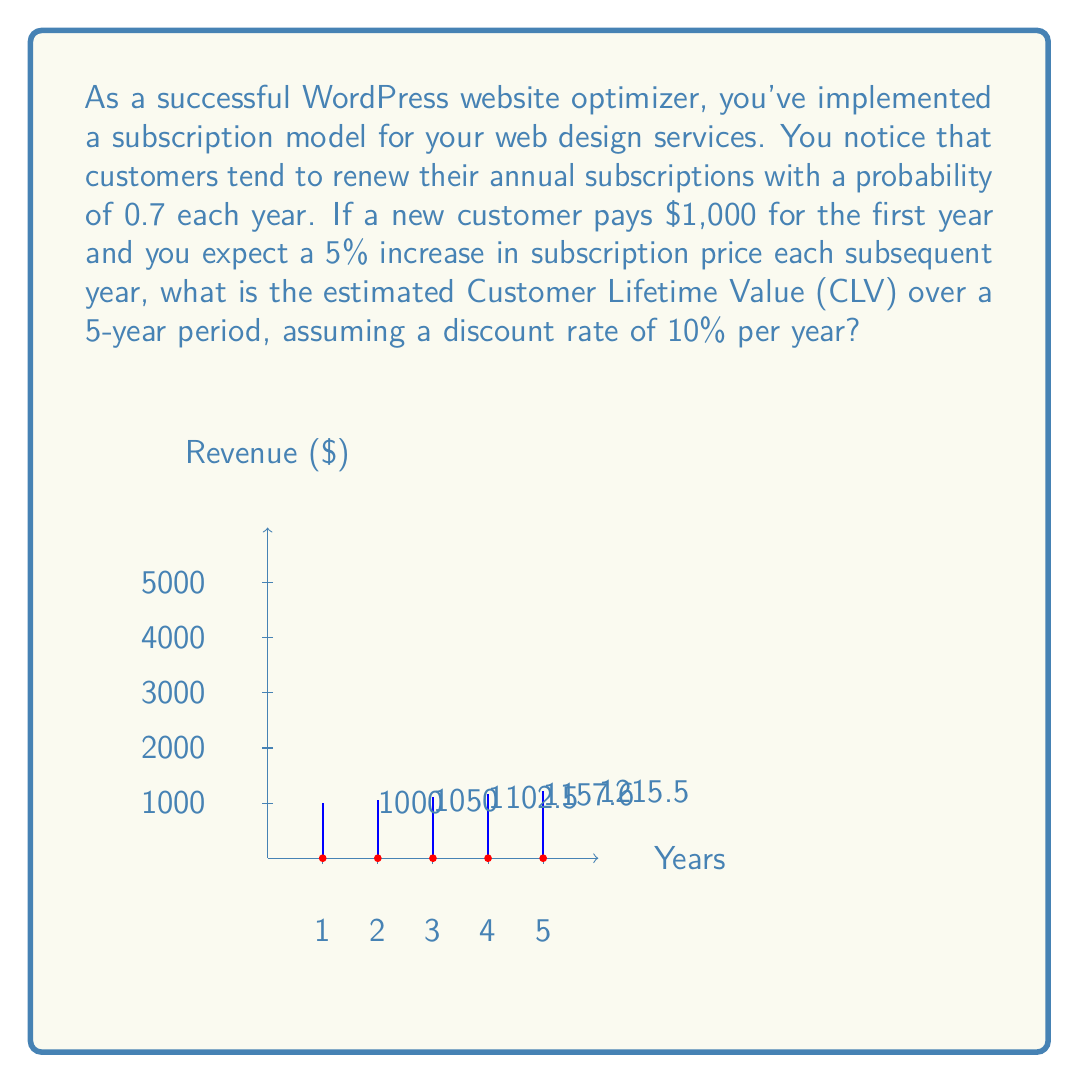Solve this math problem. To calculate the Customer Lifetime Value (CLV) over a 5-year period, we'll use the following steps:

1) First, let's calculate the expected revenue for each year:
   Year 1: $1000
   Year 2: $1000 * 1.05 = $1050
   Year 3: $1050 * 1.05 = $1102.50
   Year 4: $1102.50 * 1.05 = $1157.63
   Year 5: $1157.63 * 1.05 = $1215.51

2) Now, we need to consider the probability of a customer renewing each year:
   Year 1: 1 (initial subscription)
   Year 2: 0.7
   Year 3: 0.7 * 0.7 = 0.49
   Year 4: 0.7 * 0.7 * 0.7 = 0.343
   Year 5: 0.7 * 0.7 * 0.7 * 0.7 = 0.2401

3) We'll also apply the discount rate to each year's expected value:
   Discount factor for year t = $\frac{1}{(1 + r)^t}$, where r is the discount rate (0.10)

4) Now, let's calculate the expected value for each year:

   Year 1: $1000 * 1 * \frac{1}{(1 + 0.10)^1} = 909.09$

   Year 2: $1050 * 0.7 * \frac{1}{(1 + 0.10)^2} = 611.57$

   Year 3: $1102.50 * 0.49 * \frac{1}{(1 + 0.10)^3} = 387.42$

   Year 4: $1157.63 * 0.343 * \frac{1}{(1 + 0.10)^4} = 245.40$

   Year 5: $1215.51 * 0.2401 * \frac{1}{(1 + 0.10)^5} = 155.55$

5) The CLV is the sum of these expected values:

   CLV = $909.09 + 611.57 + 387.42 + 245.40 + 155.55 = 2309.03$

Therefore, the estimated Customer Lifetime Value over a 5-year period is $2,309.03.
Answer: $2,309.03 